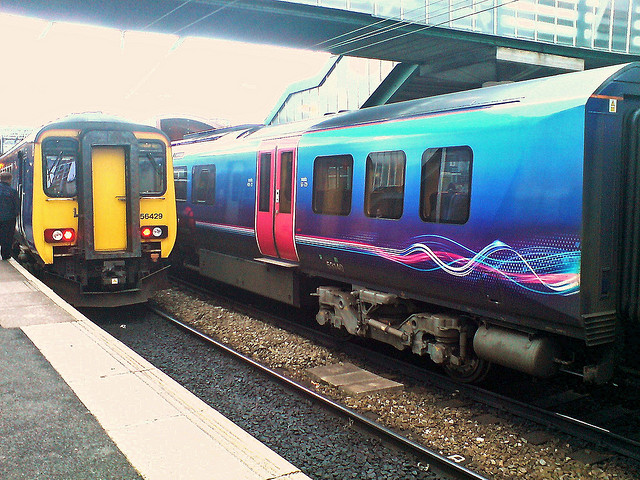Identify and read out the text in this image. 56429 